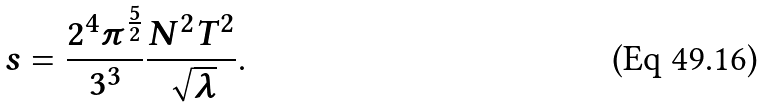Convert formula to latex. <formula><loc_0><loc_0><loc_500><loc_500>s = \frac { 2 ^ { 4 } \pi ^ { \frac { 5 } { 2 } } } { 3 ^ { 3 } } \frac { N ^ { 2 } T ^ { 2 } } { \sqrt { \lambda } } .</formula> 